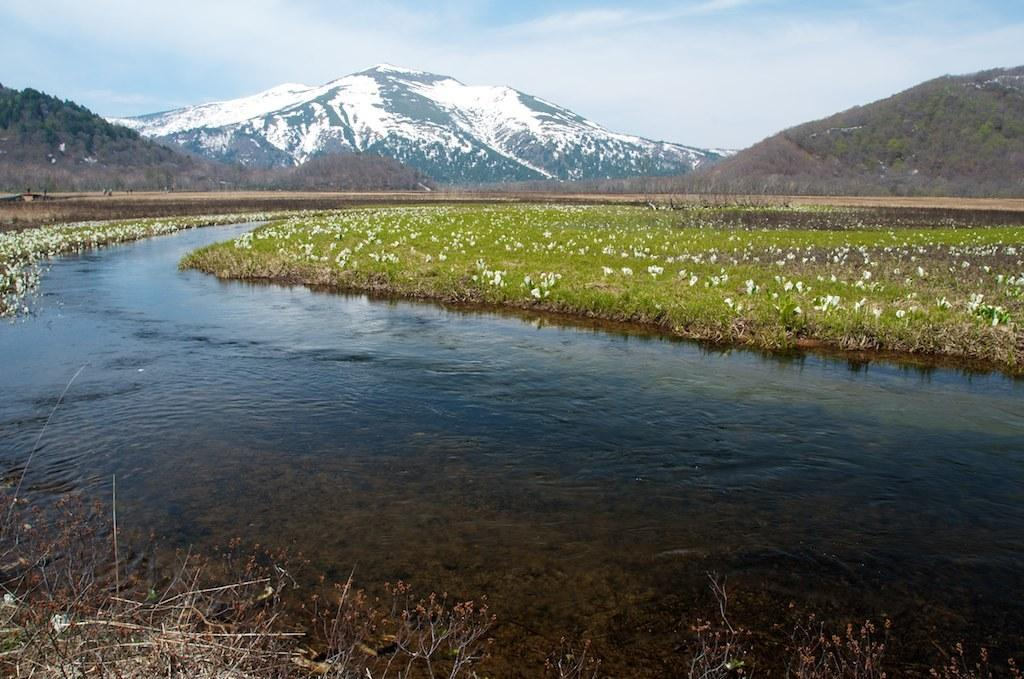What type of landscape can be seen in the image? There are hills in the image. What type of vegetation is present in the image? There are flowers and grass in the image. What is visible in the background of the image? The sky is visible in the image. What type of jellyfish can be seen swimming in the image? There are no jellyfish present in the image; it features hills, flowers, grass, and the sky. 